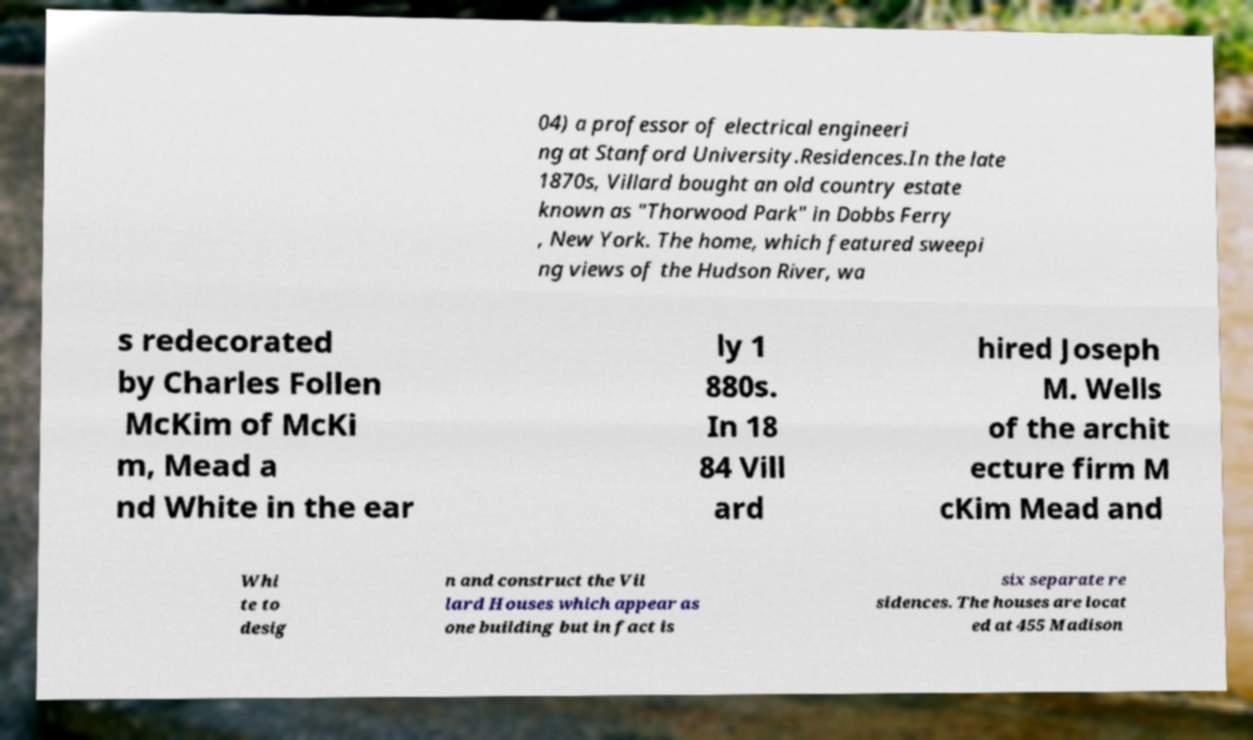Please identify and transcribe the text found in this image. 04) a professor of electrical engineeri ng at Stanford University.Residences.In the late 1870s, Villard bought an old country estate known as "Thorwood Park" in Dobbs Ferry , New York. The home, which featured sweepi ng views of the Hudson River, wa s redecorated by Charles Follen McKim of McKi m, Mead a nd White in the ear ly 1 880s. In 18 84 Vill ard hired Joseph M. Wells of the archit ecture firm M cKim Mead and Whi te to desig n and construct the Vil lard Houses which appear as one building but in fact is six separate re sidences. The houses are locat ed at 455 Madison 